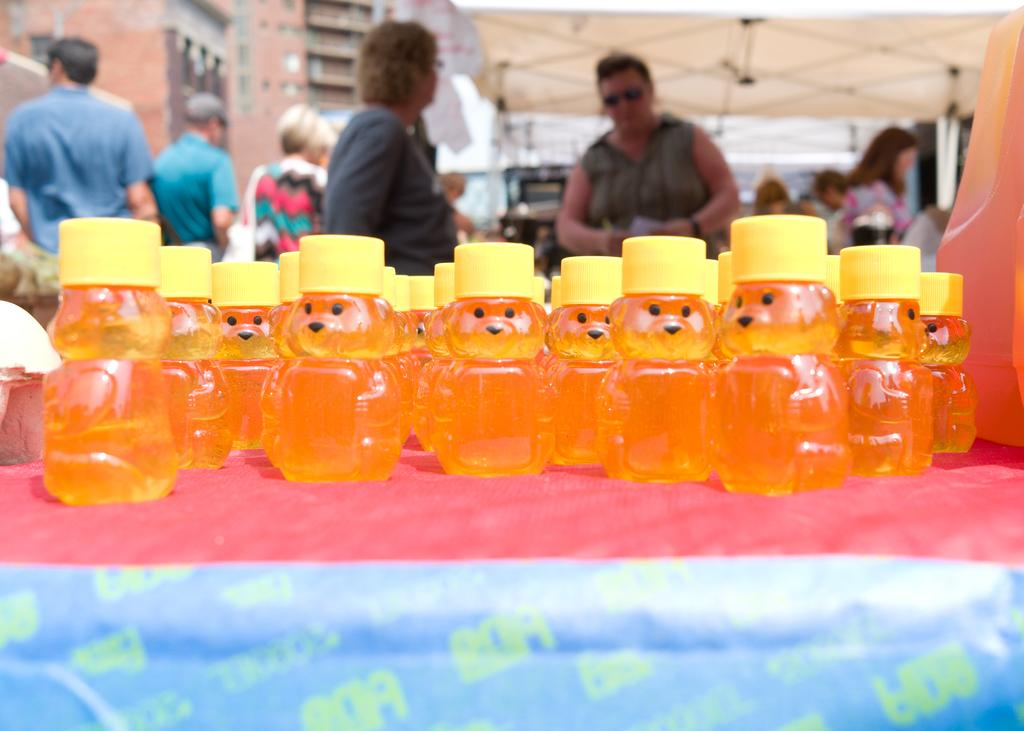What objects can be seen in the image? There are bottles in the image. Who or what else is present in the image? There are people standing in the image. What type of structure is visible in the image? There is a building in the image. What type of wood is used to construct the building in the image? There is no information about the type of wood used in the construction of the building in the image. 